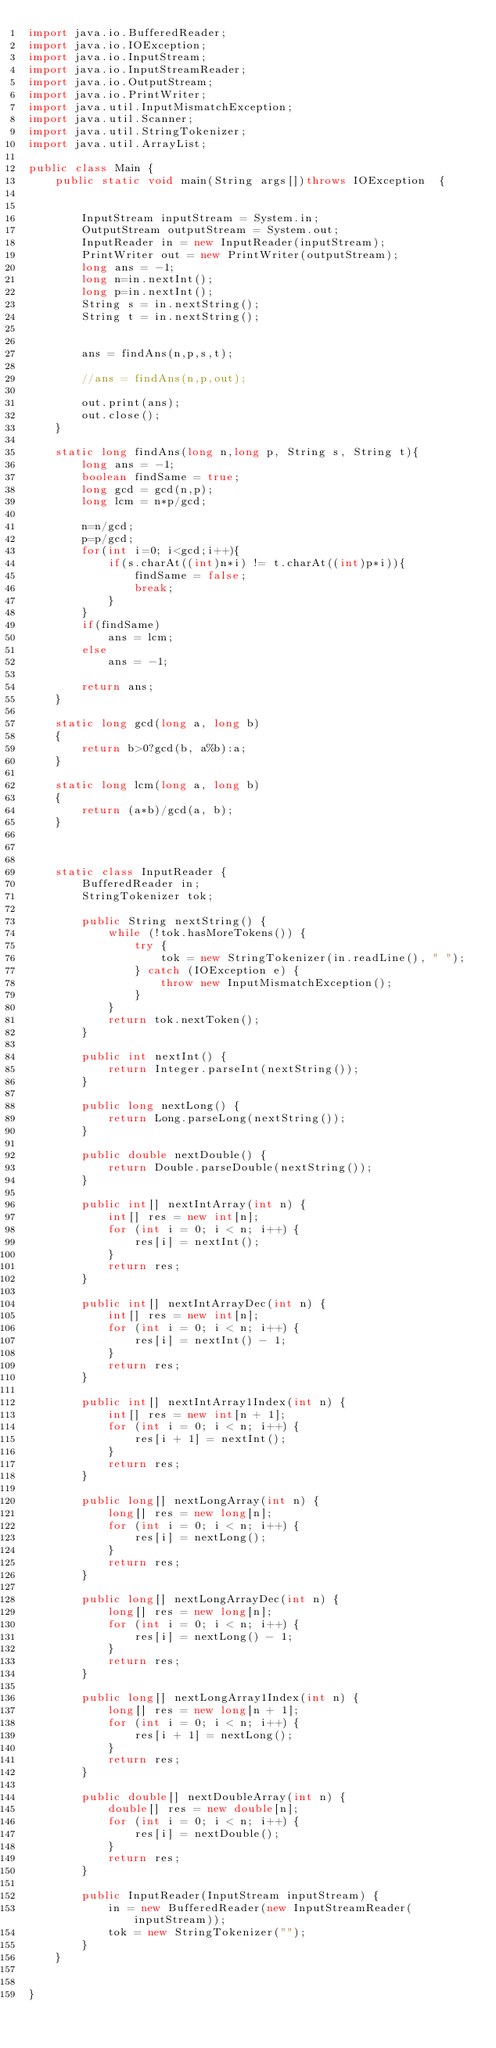<code> <loc_0><loc_0><loc_500><loc_500><_Java_>import java.io.BufferedReader;
import java.io.IOException;
import java.io.InputStream;
import java.io.InputStreamReader;
import java.io.OutputStream;
import java.io.PrintWriter;
import java.util.InputMismatchException;
import java.util.Scanner;
import java.util.StringTokenizer;
import java.util.ArrayList;
 
public class Main {
	public static void main(String args[])throws IOException  {
 
	
		InputStream inputStream = System.in;
		OutputStream outputStream = System.out;
		InputReader in = new InputReader(inputStream);
		PrintWriter out = new PrintWriter(outputStream);
		long ans = -1;
		long n=in.nextInt();
		long p=in.nextInt();
		String s = in.nextString();
		String t = in.nextString();

		
		ans = findAns(n,p,s,t);
		
		//ans = findAns(n,p,out);

		out.print(ans);
		out.close();
	}

	static long findAns(long n,long p, String s, String t){
		long ans = -1;
		boolean findSame = true;		
		long gcd = gcd(n,p);
		long lcm = n*p/gcd;
		
		n=n/gcd;
		p=p/gcd;
		for(int i=0; i<gcd;i++){
			if(s.charAt((int)n*i) != t.charAt((int)p*i)){
				findSame = false;
				break;
			}
		}
		if(findSame)
			ans = lcm;
		else
			ans = -1;		
		
		return ans;
	}
	
    static long gcd(long a, long b) 
    { 
        return b>0?gcd(b, a%b):a; 
    } 

    static long lcm(long a, long b) 
    { 
        return (a*b)/gcd(a, b); 
    } 

	
	
	static class InputReader {
		BufferedReader in;
		StringTokenizer tok;
 
		public String nextString() {
			while (!tok.hasMoreTokens()) {
				try {
					tok = new StringTokenizer(in.readLine(), " ");
				} catch (IOException e) {
					throw new InputMismatchException();
				}
			}
			return tok.nextToken();
		}
 
		public int nextInt() {
			return Integer.parseInt(nextString());
		}
 
		public long nextLong() {
			return Long.parseLong(nextString());
		}
 
		public double nextDouble() {
			return Double.parseDouble(nextString());
		}
 
		public int[] nextIntArray(int n) {
			int[] res = new int[n];
			for (int i = 0; i < n; i++) {
				res[i] = nextInt();
			}
			return res;
		}
 
		public int[] nextIntArrayDec(int n) {
			int[] res = new int[n];
			for (int i = 0; i < n; i++) {
				res[i] = nextInt() - 1;
			}
			return res;
		}
 
		public int[] nextIntArray1Index(int n) {
			int[] res = new int[n + 1];
			for (int i = 0; i < n; i++) {
				res[i + 1] = nextInt();
			}
			return res;
		}
 
		public long[] nextLongArray(int n) {
			long[] res = new long[n];
			for (int i = 0; i < n; i++) {
				res[i] = nextLong();
			}
			return res;
		}
 
		public long[] nextLongArrayDec(int n) {
			long[] res = new long[n];
			for (int i = 0; i < n; i++) {
				res[i] = nextLong() - 1;
			}
			return res;
		}
 
		public long[] nextLongArray1Index(int n) {
			long[] res = new long[n + 1];
			for (int i = 0; i < n; i++) {
				res[i + 1] = nextLong();
			}
			return res;
		}
 
		public double[] nextDoubleArray(int n) {
			double[] res = new double[n];
			for (int i = 0; i < n; i++) {
				res[i] = nextDouble();
			}
			return res;
		}
 
		public InputReader(InputStream inputStream) {
			in = new BufferedReader(new InputStreamReader(inputStream));
			tok = new StringTokenizer("");
		}
	}
 
	
}
</code> 